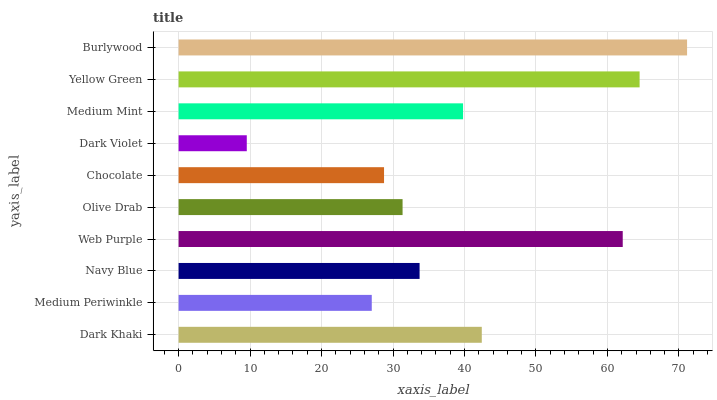Is Dark Violet the minimum?
Answer yes or no. Yes. Is Burlywood the maximum?
Answer yes or no. Yes. Is Medium Periwinkle the minimum?
Answer yes or no. No. Is Medium Periwinkle the maximum?
Answer yes or no. No. Is Dark Khaki greater than Medium Periwinkle?
Answer yes or no. Yes. Is Medium Periwinkle less than Dark Khaki?
Answer yes or no. Yes. Is Medium Periwinkle greater than Dark Khaki?
Answer yes or no. No. Is Dark Khaki less than Medium Periwinkle?
Answer yes or no. No. Is Medium Mint the high median?
Answer yes or no. Yes. Is Navy Blue the low median?
Answer yes or no. Yes. Is Medium Periwinkle the high median?
Answer yes or no. No. Is Yellow Green the low median?
Answer yes or no. No. 